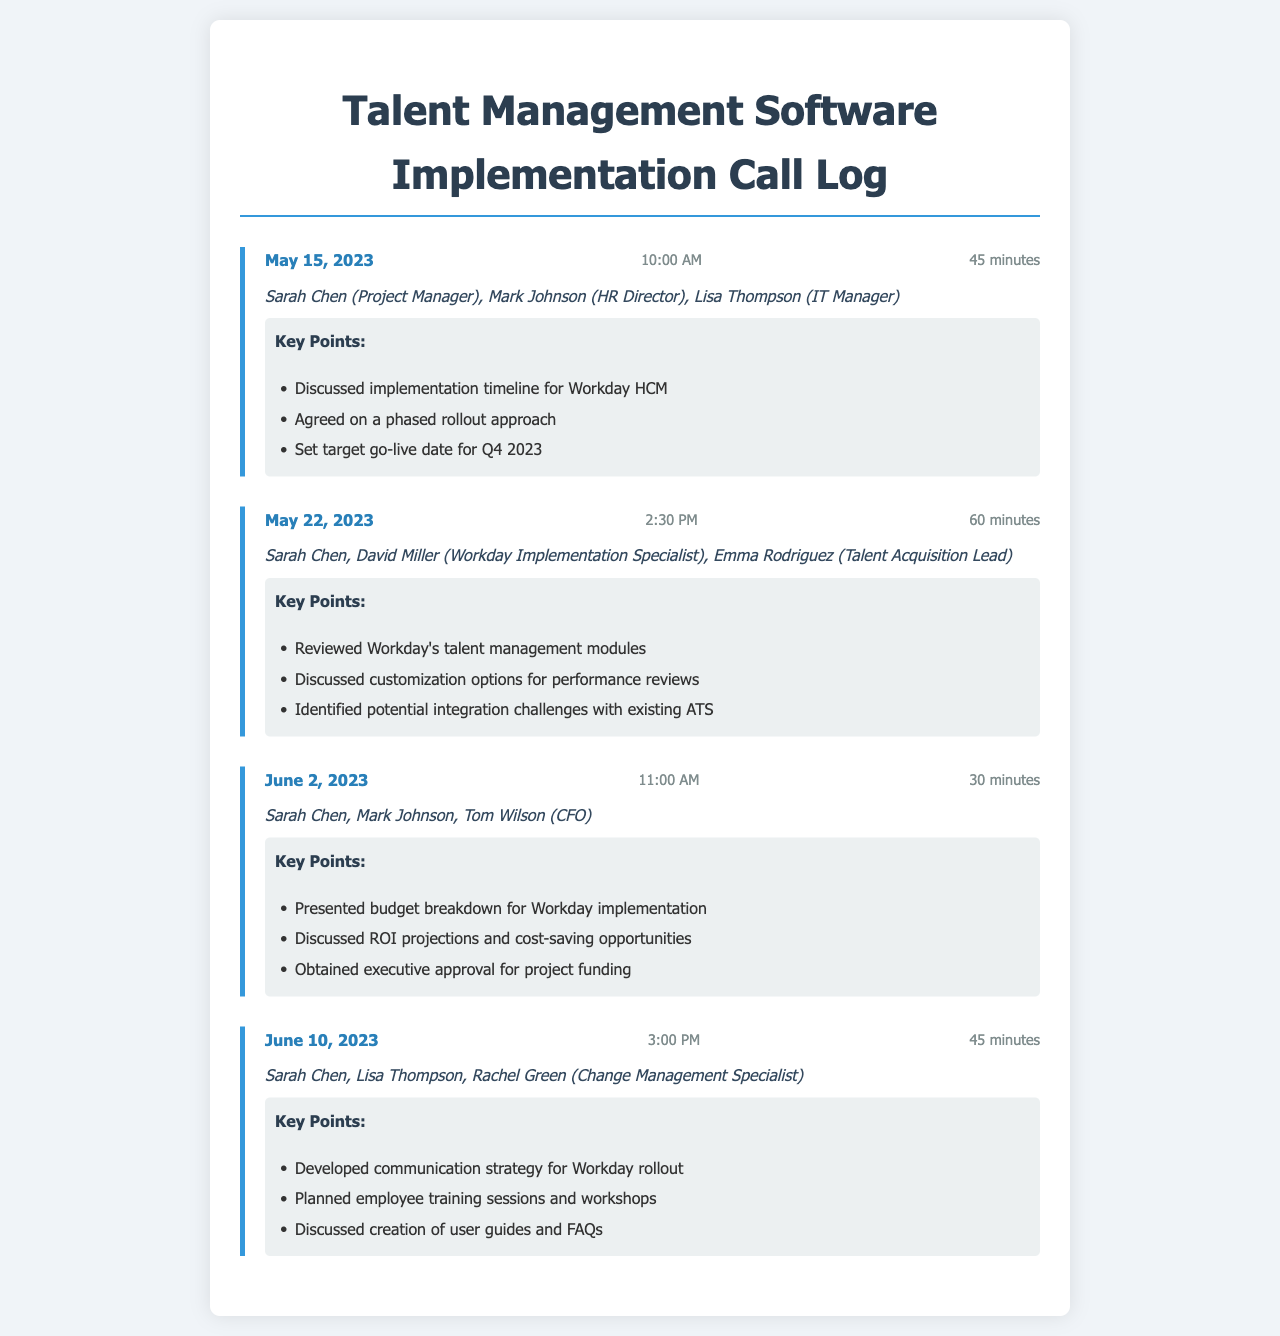what is the date of the first conference call? The date of the first call is specified in the document under the call logs, which is May 15, 2023.
Answer: May 15, 2023 who was the HR Director participating in the calls? The participant listed as the HR Director in the calls is Mark Johnson.
Answer: Mark Johnson what is the target go-live date for the project? The target go-live date for the project is mentioned in the key points of the first call log, which is set for Q4 2023.
Answer: Q4 2023 how long was the second call? The second call's duration is noted in the call log, which is 60 minutes.
Answer: 60 minutes which software was being discussed for implementation? The software being discussed for implementation is clearly stated in the document, identified as Workday HCM.
Answer: Workday HCM what key point was agreed upon in the first call? The key point agreed upon in the first call was the phased rollout approach.
Answer: phased rollout approach how many calls were logged in the document? The document contains a total of four call logs, as noted in the structure of the document.
Answer: four who obtained executive approval for project funding? The individual who obtained executive approval for project funding is mentioned in the third call, identified as Tom Wilson, the CFO.
Answer: Tom Wilson what topic was discussed related to employee training in the fourth call? The topic discussed related to employee training in the fourth call included planning employee training sessions and workshops.
Answer: training sessions and workshops 